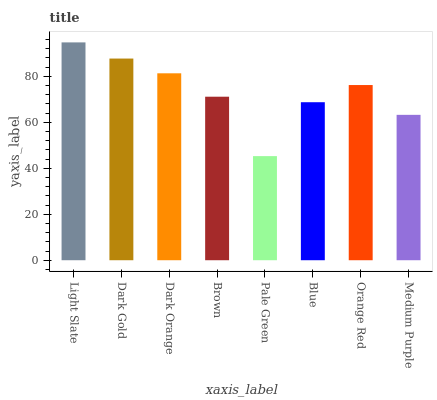Is Pale Green the minimum?
Answer yes or no. Yes. Is Light Slate the maximum?
Answer yes or no. Yes. Is Dark Gold the minimum?
Answer yes or no. No. Is Dark Gold the maximum?
Answer yes or no. No. Is Light Slate greater than Dark Gold?
Answer yes or no. Yes. Is Dark Gold less than Light Slate?
Answer yes or no. Yes. Is Dark Gold greater than Light Slate?
Answer yes or no. No. Is Light Slate less than Dark Gold?
Answer yes or no. No. Is Orange Red the high median?
Answer yes or no. Yes. Is Brown the low median?
Answer yes or no. Yes. Is Pale Green the high median?
Answer yes or no. No. Is Blue the low median?
Answer yes or no. No. 